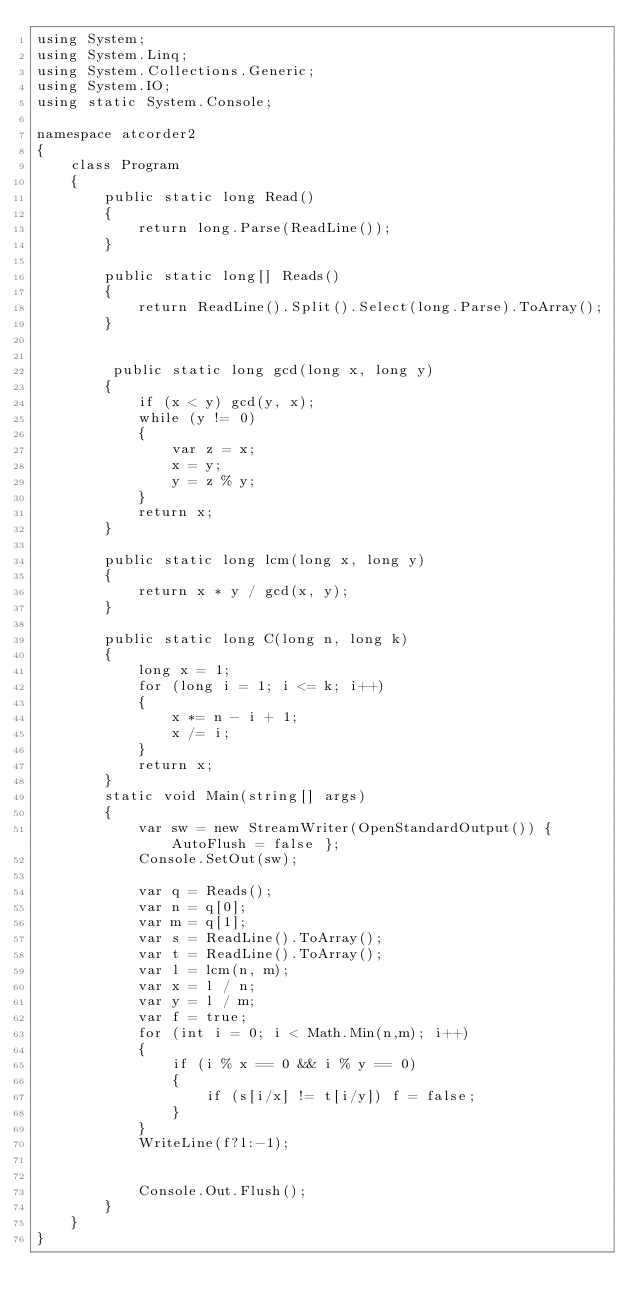<code> <loc_0><loc_0><loc_500><loc_500><_C#_>using System;
using System.Linq;
using System.Collections.Generic;
using System.IO;
using static System.Console;

namespace atcorder2
{
    class Program
    {
        public static long Read()
        {
            return long.Parse(ReadLine());
        }

        public static long[] Reads()
        {
            return ReadLine().Split().Select(long.Parse).ToArray();
        }

        
         public static long gcd(long x, long y)
        {
            if (x < y) gcd(y, x);
            while (y != 0)
            {
                var z = x;
                x = y;
                y = z % y;
            }
            return x;
        }

        public static long lcm(long x, long y)
        {
            return x * y / gcd(x, y);
        } 

        public static long C(long n, long k)
        {
            long x = 1;
            for (long i = 1; i <= k; i++)
            {
                x *= n - i + 1;
                x /= i;
            }
            return x;
        }
        static void Main(string[] args)
        {
            var sw = new StreamWriter(OpenStandardOutput()) { AutoFlush = false };
            Console.SetOut(sw);

            var q = Reads();
            var n = q[0];
            var m = q[1];
            var s = ReadLine().ToArray();
            var t = ReadLine().ToArray();
            var l = lcm(n, m);
            var x = l / n; 
            var y = l / m;
            var f = true;
            for (int i = 0; i < Math.Min(n,m); i++)
            {
                if (i % x == 0 && i % y == 0)
                {
                    if (s[i/x] != t[i/y]) f = false;
                }
            }
            WriteLine(f?l:-1);
           

            Console.Out.Flush();
        }
    }
}
</code> 